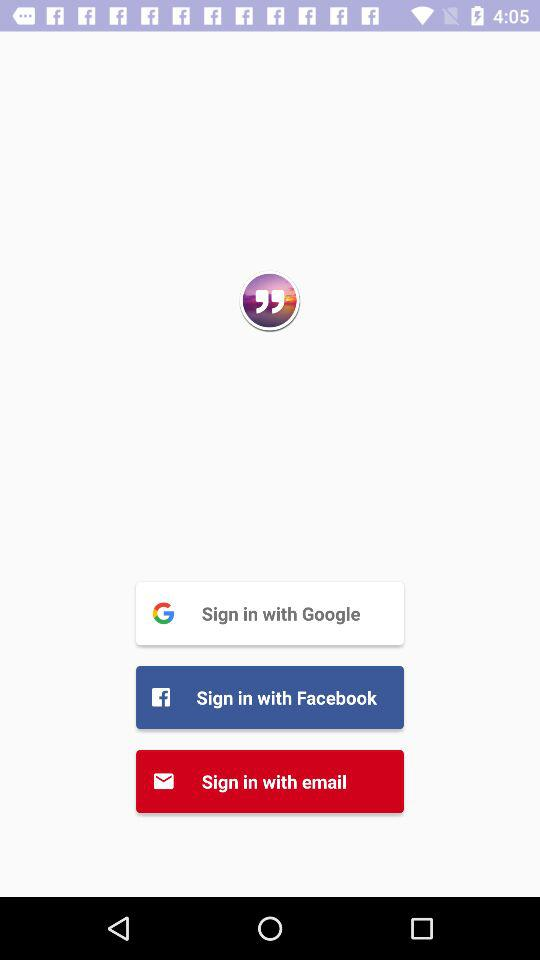Which options are given to sign in with? The options are "Google", "Facebook" and "email". 